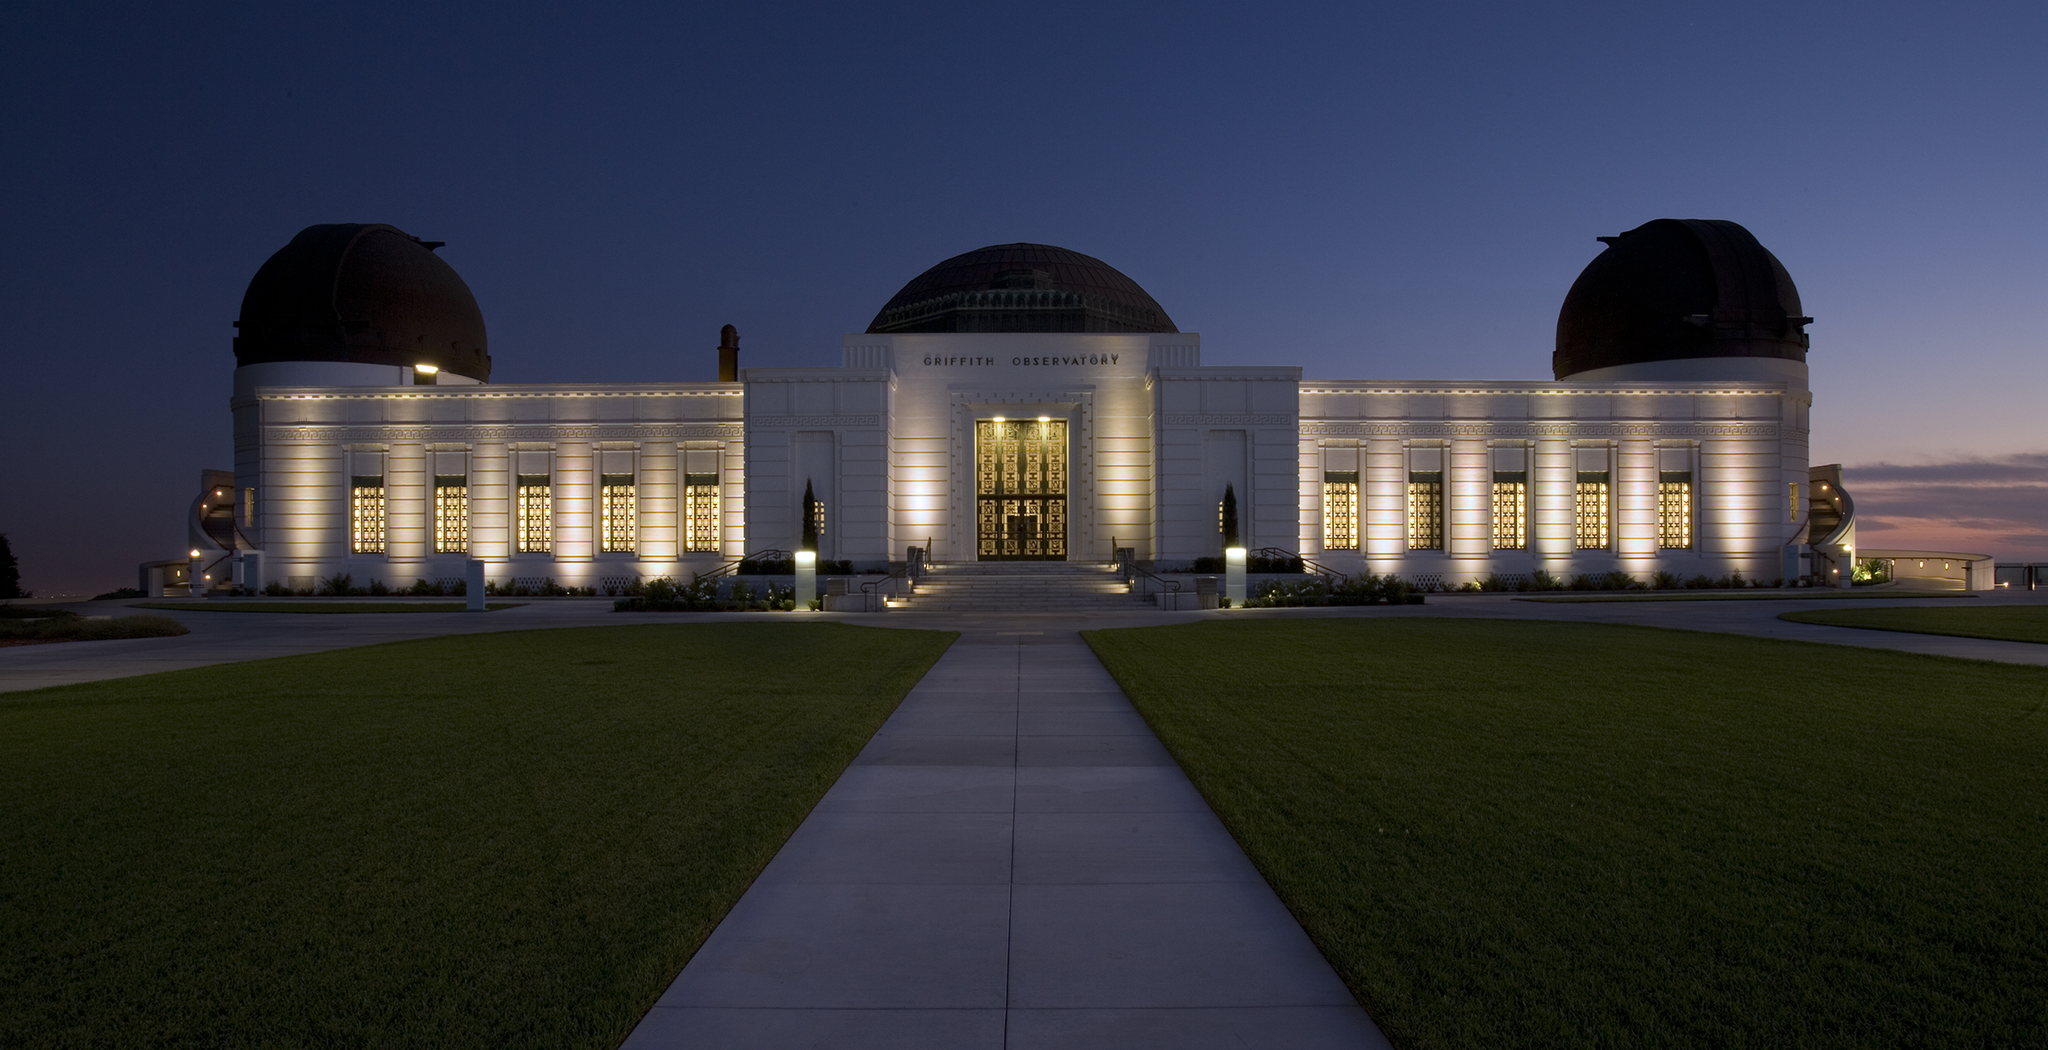Create a poem inspired by this image. Amidst the twilight's gentle cloak,
The observatory stands to provoke,
Dreams of stars and distant lands,
Under the sky where silence spans.
White walls gleam in evening's light,
Domes casting shadows, pure and bright.
A cosmic dance in nature's frame,
Where Earth and heavens meet in fame.
Green lawn beneath the starry sweep,
A tranquil place where visions leap.
Here, wisdom whispers in the air,
Inviting all to stop and stare.
In this serene, majestic court,
The cosmos and our thoughts consort,
To journey far from human plight,
On wings of wonder, light as night. 